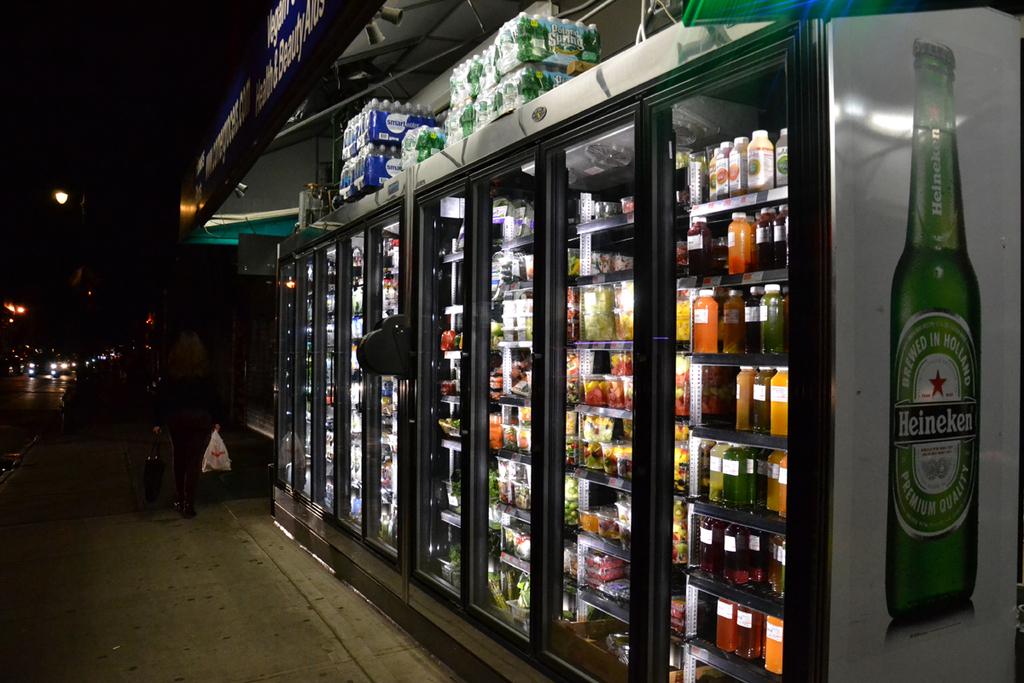What is the brewery featured on the side of the fridge?
Offer a very short reply. Heineken. What is the name of the beer on the side of the fridge?
Offer a terse response. Heineken. 